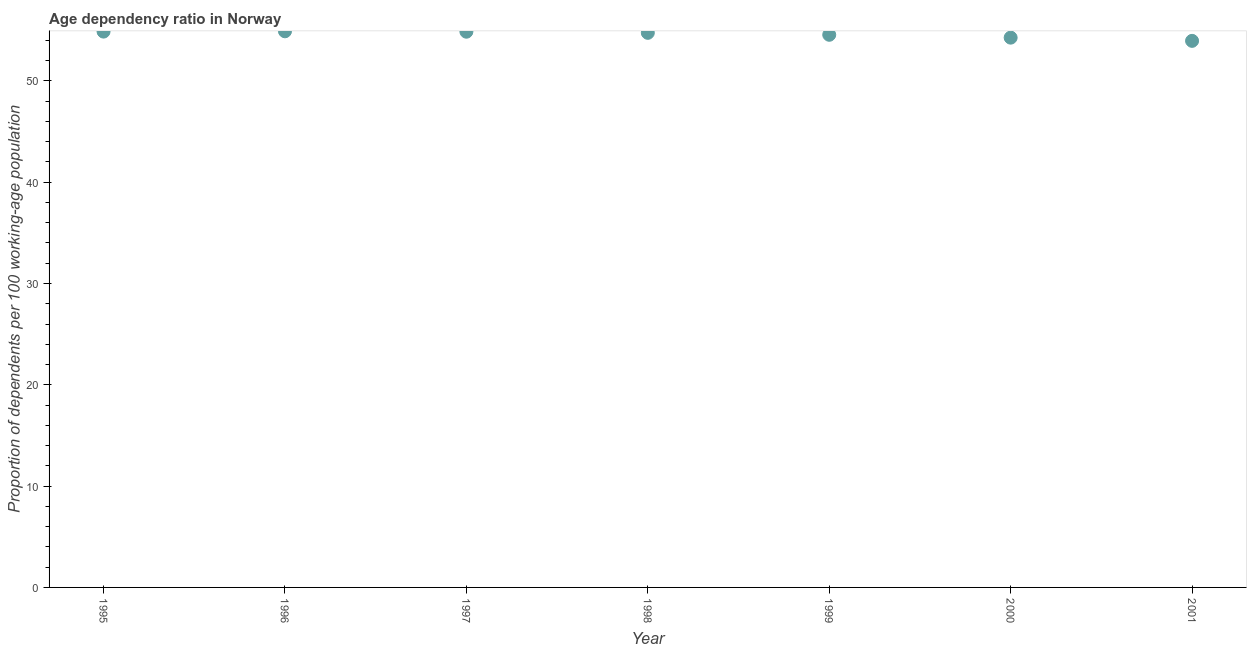What is the age dependency ratio in 2001?
Give a very brief answer. 53.95. Across all years, what is the maximum age dependency ratio?
Make the answer very short. 54.89. Across all years, what is the minimum age dependency ratio?
Your response must be concise. 53.95. In which year was the age dependency ratio minimum?
Make the answer very short. 2001. What is the sum of the age dependency ratio?
Your answer should be very brief. 382.13. What is the difference between the age dependency ratio in 1997 and 1998?
Make the answer very short. 0.11. What is the average age dependency ratio per year?
Your answer should be compact. 54.59. What is the median age dependency ratio?
Your answer should be compact. 54.74. What is the ratio of the age dependency ratio in 1998 to that in 2000?
Offer a terse response. 1.01. Is the age dependency ratio in 1999 less than that in 2000?
Provide a succinct answer. No. What is the difference between the highest and the second highest age dependency ratio?
Offer a terse response. 0.03. Is the sum of the age dependency ratio in 1997 and 1999 greater than the maximum age dependency ratio across all years?
Provide a short and direct response. Yes. What is the difference between the highest and the lowest age dependency ratio?
Provide a succinct answer. 0.94. In how many years, is the age dependency ratio greater than the average age dependency ratio taken over all years?
Your answer should be very brief. 4. Does the age dependency ratio monotonically increase over the years?
Make the answer very short. No. How many dotlines are there?
Keep it short and to the point. 1. How many years are there in the graph?
Your response must be concise. 7. Are the values on the major ticks of Y-axis written in scientific E-notation?
Offer a terse response. No. Does the graph contain any zero values?
Offer a terse response. No. Does the graph contain grids?
Provide a succinct answer. No. What is the title of the graph?
Your answer should be compact. Age dependency ratio in Norway. What is the label or title of the X-axis?
Give a very brief answer. Year. What is the label or title of the Y-axis?
Make the answer very short. Proportion of dependents per 100 working-age population. What is the Proportion of dependents per 100 working-age population in 1995?
Provide a succinct answer. 54.87. What is the Proportion of dependents per 100 working-age population in 1996?
Your answer should be very brief. 54.89. What is the Proportion of dependents per 100 working-age population in 1997?
Provide a succinct answer. 54.85. What is the Proportion of dependents per 100 working-age population in 1998?
Give a very brief answer. 54.74. What is the Proportion of dependents per 100 working-age population in 1999?
Ensure brevity in your answer.  54.55. What is the Proportion of dependents per 100 working-age population in 2000?
Provide a succinct answer. 54.27. What is the Proportion of dependents per 100 working-age population in 2001?
Offer a very short reply. 53.95. What is the difference between the Proportion of dependents per 100 working-age population in 1995 and 1996?
Your answer should be compact. -0.03. What is the difference between the Proportion of dependents per 100 working-age population in 1995 and 1997?
Your answer should be very brief. 0.01. What is the difference between the Proportion of dependents per 100 working-age population in 1995 and 1998?
Provide a succinct answer. 0.12. What is the difference between the Proportion of dependents per 100 working-age population in 1995 and 1999?
Provide a short and direct response. 0.32. What is the difference between the Proportion of dependents per 100 working-age population in 1995 and 2000?
Provide a succinct answer. 0.6. What is the difference between the Proportion of dependents per 100 working-age population in 1995 and 2001?
Offer a terse response. 0.91. What is the difference between the Proportion of dependents per 100 working-age population in 1996 and 1997?
Provide a succinct answer. 0.04. What is the difference between the Proportion of dependents per 100 working-age population in 1996 and 1998?
Keep it short and to the point. 0.15. What is the difference between the Proportion of dependents per 100 working-age population in 1996 and 1999?
Your response must be concise. 0.34. What is the difference between the Proportion of dependents per 100 working-age population in 1996 and 2000?
Give a very brief answer. 0.63. What is the difference between the Proportion of dependents per 100 working-age population in 1996 and 2001?
Offer a very short reply. 0.94. What is the difference between the Proportion of dependents per 100 working-age population in 1997 and 1998?
Your answer should be compact. 0.11. What is the difference between the Proportion of dependents per 100 working-age population in 1997 and 1999?
Your answer should be very brief. 0.3. What is the difference between the Proportion of dependents per 100 working-age population in 1997 and 2000?
Your answer should be very brief. 0.59. What is the difference between the Proportion of dependents per 100 working-age population in 1997 and 2001?
Make the answer very short. 0.9. What is the difference between the Proportion of dependents per 100 working-age population in 1998 and 1999?
Give a very brief answer. 0.19. What is the difference between the Proportion of dependents per 100 working-age population in 1998 and 2000?
Your answer should be compact. 0.47. What is the difference between the Proportion of dependents per 100 working-age population in 1998 and 2001?
Your response must be concise. 0.79. What is the difference between the Proportion of dependents per 100 working-age population in 1999 and 2000?
Keep it short and to the point. 0.28. What is the difference between the Proportion of dependents per 100 working-age population in 1999 and 2001?
Offer a very short reply. 0.6. What is the difference between the Proportion of dependents per 100 working-age population in 2000 and 2001?
Give a very brief answer. 0.32. What is the ratio of the Proportion of dependents per 100 working-age population in 1995 to that in 1996?
Your response must be concise. 1. What is the ratio of the Proportion of dependents per 100 working-age population in 1995 to that in 1997?
Your response must be concise. 1. What is the ratio of the Proportion of dependents per 100 working-age population in 1995 to that in 1998?
Keep it short and to the point. 1. What is the ratio of the Proportion of dependents per 100 working-age population in 1996 to that in 1998?
Your answer should be very brief. 1. What is the ratio of the Proportion of dependents per 100 working-age population in 1996 to that in 2001?
Your answer should be compact. 1.02. What is the ratio of the Proportion of dependents per 100 working-age population in 1997 to that in 1999?
Offer a terse response. 1.01. What is the ratio of the Proportion of dependents per 100 working-age population in 1997 to that in 2000?
Your answer should be compact. 1.01. What is the ratio of the Proportion of dependents per 100 working-age population in 1997 to that in 2001?
Give a very brief answer. 1.02. What is the ratio of the Proportion of dependents per 100 working-age population in 1998 to that in 1999?
Provide a succinct answer. 1. What is the ratio of the Proportion of dependents per 100 working-age population in 1998 to that in 2000?
Provide a succinct answer. 1.01. What is the ratio of the Proportion of dependents per 100 working-age population in 1999 to that in 2001?
Give a very brief answer. 1.01. 